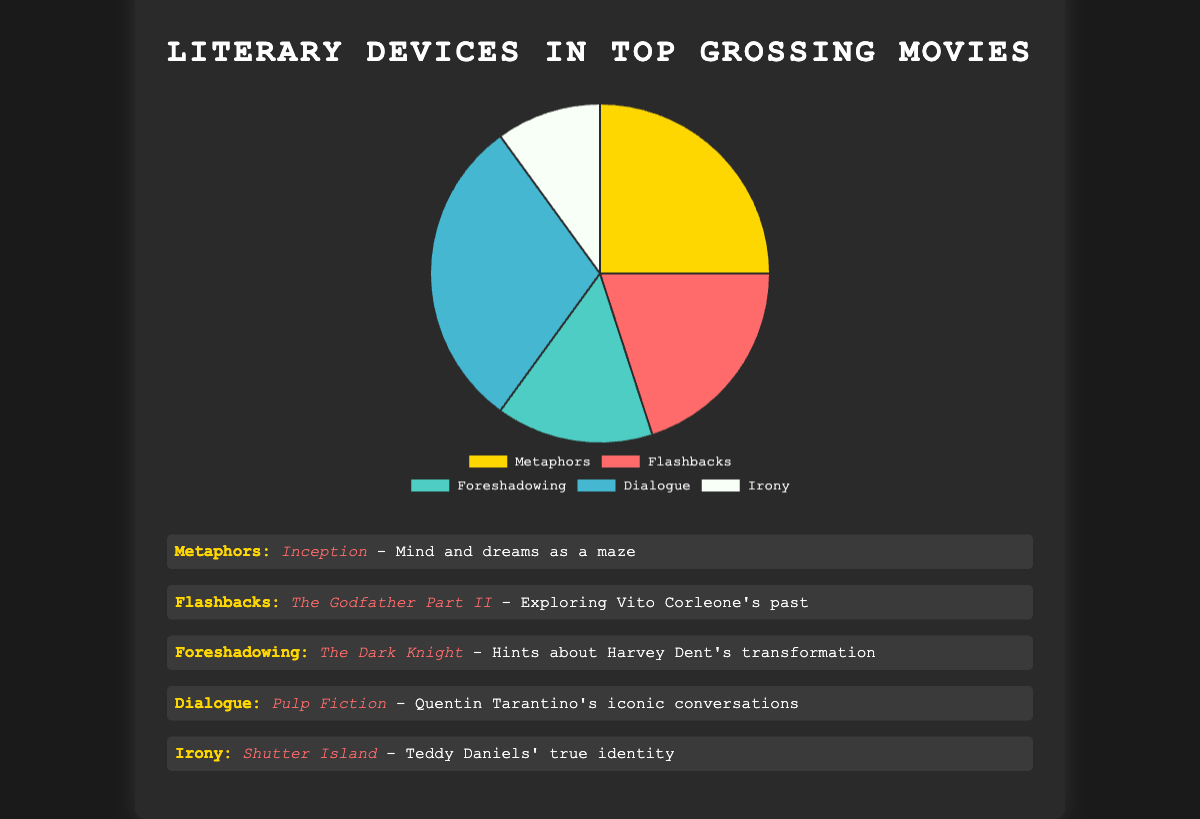What's the most used literary device among top-grossing movies? The pie chart shows the percentages of various literary devices used. Dialogue occupies the largest percentage, indicating it is the most used device.
Answer: Dialogue Which literary device is used the least in top-grossing movies? By examining the pie chart, Irony has the smallest segment, representing 10%. This makes it the least used literary device.
Answer: Irony How much more prevalent are Metaphors compared to Irony? Metaphors represent 25% and Irony represents 10%. The difference in their prevalence is 25% - 10% = 15%.
Answer: 15% If you combine the percentages for Flashbacks and Foreshadowing, what do you get? Flashbacks account for 20% and Foreshadowing accounts for 15%. Adding these together gives 20% + 15% = 35%.
Answer: 35% Which literary device is depicted using the color representing Quentin Tarantino's iconic conversations in Pulp Fiction? From the color representation in the chart, Dialogue is associated with Quentin Tarantino's iconic conversations in Pulp Fiction.
Answer: Dialogue Is Flashbacks more or less common than Foreshadowing in top-grossing movies? By how much? According to the pie chart, Flashbacks are 20% while Foreshadowing is 15%. Flashbacks are 5% more common than Foreshadowing: 20% - 15% = 5%.
Answer: 5% more Which three literary devices together make up more than half (over 50%) of the uses in top-grossing movies? The three devices with the highest percentages are Dialogue (30%), Metaphors (25%), and Flashbacks (20%). Summing these gives us 30% + 25% + 20% = 75%, which is over half.
Answer: Dialogue, Metaphors, Flashbacks What is the percentage difference between the use of Metaphors and Flashbacks? Metaphors account for 25% while Flashbacks account for 20%. The difference is 25% - 20% = 5%.
Answer: 5% What literary device accounts for a quarter of the uses in top-grossing movies? According to the chart, Metaphors account for exactly 25%, which is a quarter.
Answer: Metaphors Looking at the pie chart, which literary device uses visual imagery related to dreams and the mind, and in which movie is this illustrated? The pie chart and the accompanying list show that Metaphors represent "Mind and dreams as a maze" in the movie Inception.
Answer: Metaphors, Inception 